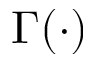Convert formula to latex. <formula><loc_0><loc_0><loc_500><loc_500>\Gamma ( \cdot )</formula> 